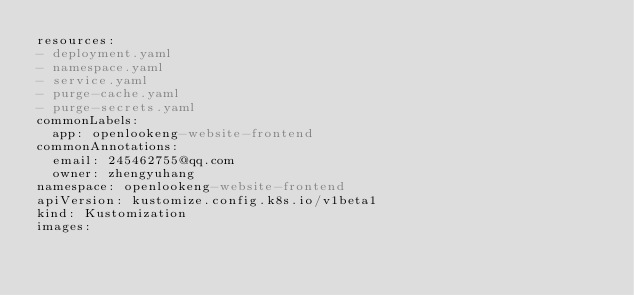Convert code to text. <code><loc_0><loc_0><loc_500><loc_500><_YAML_>resources:
- deployment.yaml
- namespace.yaml
- service.yaml
- purge-cache.yaml
- purge-secrets.yaml
commonLabels:
  app: openlookeng-website-frontend
commonAnnotations:
  email: 245462755@qq.com
  owner: zhengyuhang
namespace: openlookeng-website-frontend
apiVersion: kustomize.config.k8s.io/v1beta1
kind: Kustomization
images:</code> 